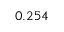<formula> <loc_0><loc_0><loc_500><loc_500>0 . 2 5 4</formula> 